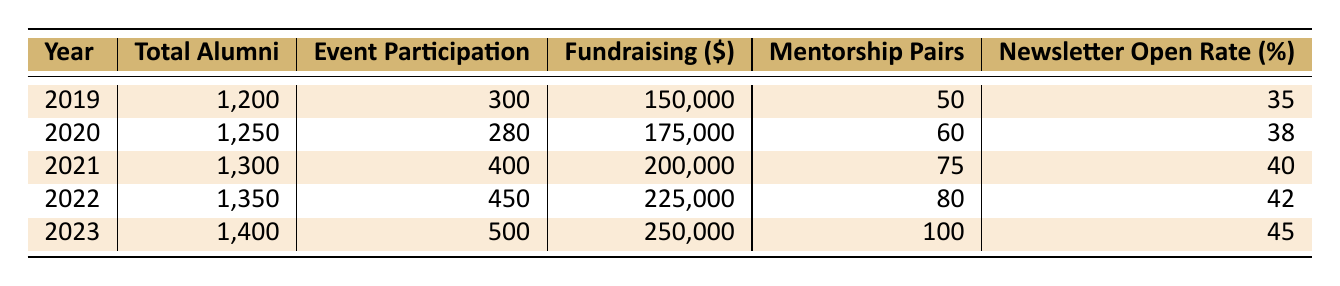What was the highest event participation recorded? Looking at the "Event Participation" column, the highest value is 500 in the year 2023.
Answer: 500 What was the total fundraising amount in 2021? The "Fundraising ($)" column shows that in 2021, the amount was 200,000.
Answer: 200,000 What is the change in total alumni from 2019 to 2023? The total alumni in 2019 was 1,200 and in 2023 it was 1,400. The change is 1,400 - 1,200 = 200.
Answer: 200 What year had the lowest newsletter open rate? Reviewing the "Newsletter Open Rate (%)" column, 2019 had the lowest rate at 35%.
Answer: 2019 How many more mentorship pairs were there in 2023 compared to 2019? In 2023, there were 100 mentorship pairs and in 2019 there were 50 pairs. The difference is 100 - 50 = 50.
Answer: 50 What was the average fundraising amount over the five years? The fundraising amounts are 150,000, 175,000, 200,000, 225,000, and 250,000. The sum is 1,000,000, and dividing by 5 gives an average of 200,000.
Answer: 200,000 Did event participation increase every year? Comparing each year, 2019 (300), 2020 (280), 2021 (400), 2022 (450), and 2023 (500), we see that 2020 decreased from 2019. Therefore, it did not increase every year.
Answer: No What can be said about the trend of newsletter open rates over the years? The newsletter open rates show a consistent increase: 35% in 2019, 38% in 2020, 40% in 2021, 42% in 2022, and 45% in 2023. This indicates a positive trend.
Answer: They increased each year What was the total amount raised in fundraising from 2019 to 2023? Summing the fundraising amounts for each year gives: 150,000 + 175,000 + 200,000 + 225,000 + 250,000 = 1,000,000.
Answer: 1,000,000 What year had the highest total alumni count and how many were there? The "Total Alumni" column indicates that in 2023, the count was 1,400, which is the highest among the years listed.
Answer: 2023, 1,400 